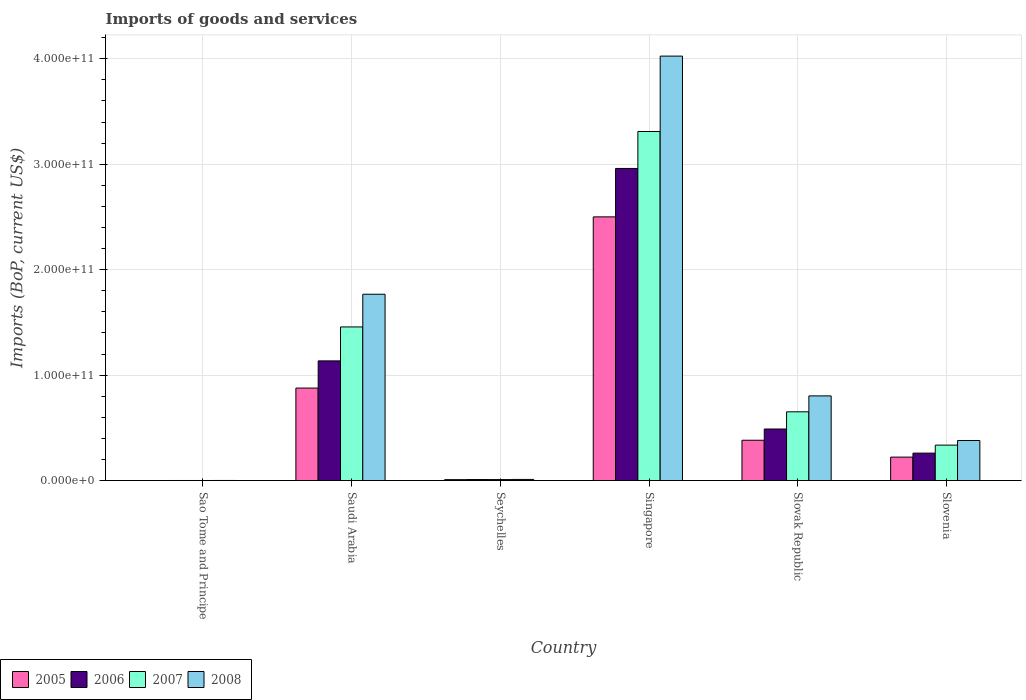How many different coloured bars are there?
Keep it short and to the point. 4. How many groups of bars are there?
Offer a very short reply. 6. Are the number of bars on each tick of the X-axis equal?
Your answer should be compact. Yes. How many bars are there on the 1st tick from the right?
Your answer should be very brief. 4. What is the label of the 6th group of bars from the left?
Offer a very short reply. Slovenia. In how many cases, is the number of bars for a given country not equal to the number of legend labels?
Provide a short and direct response. 0. What is the amount spent on imports in 2007 in Singapore?
Ensure brevity in your answer.  3.31e+11. Across all countries, what is the maximum amount spent on imports in 2006?
Your response must be concise. 2.96e+11. Across all countries, what is the minimum amount spent on imports in 2005?
Your answer should be very brief. 5.27e+07. In which country was the amount spent on imports in 2008 maximum?
Make the answer very short. Singapore. In which country was the amount spent on imports in 2007 minimum?
Your response must be concise. Sao Tome and Principe. What is the total amount spent on imports in 2006 in the graph?
Give a very brief answer. 4.85e+11. What is the difference between the amount spent on imports in 2008 in Saudi Arabia and that in Seychelles?
Your response must be concise. 1.76e+11. What is the difference between the amount spent on imports in 2006 in Seychelles and the amount spent on imports in 2007 in Sao Tome and Principe?
Provide a short and direct response. 9.01e+08. What is the average amount spent on imports in 2008 per country?
Make the answer very short. 1.16e+11. What is the difference between the amount spent on imports of/in 2008 and amount spent on imports of/in 2005 in Slovenia?
Offer a terse response. 1.58e+1. In how many countries, is the amount spent on imports in 2007 greater than 300000000000 US$?
Provide a short and direct response. 1. What is the ratio of the amount spent on imports in 2006 in Saudi Arabia to that in Seychelles?
Ensure brevity in your answer.  115.28. Is the difference between the amount spent on imports in 2008 in Sao Tome and Principe and Seychelles greater than the difference between the amount spent on imports in 2005 in Sao Tome and Principe and Seychelles?
Give a very brief answer. No. What is the difference between the highest and the second highest amount spent on imports in 2008?
Offer a terse response. 2.26e+11. What is the difference between the highest and the lowest amount spent on imports in 2008?
Provide a short and direct response. 4.02e+11. In how many countries, is the amount spent on imports in 2005 greater than the average amount spent on imports in 2005 taken over all countries?
Give a very brief answer. 2. What does the 1st bar from the right in Slovak Republic represents?
Provide a short and direct response. 2008. Is it the case that in every country, the sum of the amount spent on imports in 2007 and amount spent on imports in 2005 is greater than the amount spent on imports in 2006?
Offer a terse response. Yes. Are all the bars in the graph horizontal?
Make the answer very short. No. How many countries are there in the graph?
Keep it short and to the point. 6. What is the difference between two consecutive major ticks on the Y-axis?
Your answer should be compact. 1.00e+11. Are the values on the major ticks of Y-axis written in scientific E-notation?
Your answer should be compact. Yes. How many legend labels are there?
Provide a short and direct response. 4. What is the title of the graph?
Ensure brevity in your answer.  Imports of goods and services. What is the label or title of the X-axis?
Make the answer very short. Country. What is the label or title of the Y-axis?
Offer a terse response. Imports (BoP, current US$). What is the Imports (BoP, current US$) of 2005 in Sao Tome and Principe?
Your response must be concise. 5.27e+07. What is the Imports (BoP, current US$) of 2006 in Sao Tome and Principe?
Provide a short and direct response. 7.70e+07. What is the Imports (BoP, current US$) of 2007 in Sao Tome and Principe?
Your answer should be very brief. 8.35e+07. What is the Imports (BoP, current US$) in 2008 in Sao Tome and Principe?
Give a very brief answer. 1.14e+08. What is the Imports (BoP, current US$) in 2005 in Saudi Arabia?
Your answer should be very brief. 8.77e+1. What is the Imports (BoP, current US$) of 2006 in Saudi Arabia?
Your answer should be very brief. 1.13e+11. What is the Imports (BoP, current US$) in 2007 in Saudi Arabia?
Offer a terse response. 1.46e+11. What is the Imports (BoP, current US$) in 2008 in Saudi Arabia?
Give a very brief answer. 1.77e+11. What is the Imports (BoP, current US$) in 2005 in Seychelles?
Your response must be concise. 8.85e+08. What is the Imports (BoP, current US$) in 2006 in Seychelles?
Ensure brevity in your answer.  9.85e+08. What is the Imports (BoP, current US$) of 2007 in Seychelles?
Make the answer very short. 9.49e+08. What is the Imports (BoP, current US$) in 2008 in Seychelles?
Provide a short and direct response. 1.08e+09. What is the Imports (BoP, current US$) in 2005 in Singapore?
Ensure brevity in your answer.  2.50e+11. What is the Imports (BoP, current US$) of 2006 in Singapore?
Offer a terse response. 2.96e+11. What is the Imports (BoP, current US$) of 2007 in Singapore?
Make the answer very short. 3.31e+11. What is the Imports (BoP, current US$) in 2008 in Singapore?
Give a very brief answer. 4.03e+11. What is the Imports (BoP, current US$) of 2005 in Slovak Republic?
Keep it short and to the point. 3.82e+1. What is the Imports (BoP, current US$) of 2006 in Slovak Republic?
Ensure brevity in your answer.  4.89e+1. What is the Imports (BoP, current US$) in 2007 in Slovak Republic?
Provide a succinct answer. 6.52e+1. What is the Imports (BoP, current US$) of 2008 in Slovak Republic?
Your answer should be very brief. 8.03e+1. What is the Imports (BoP, current US$) in 2005 in Slovenia?
Offer a terse response. 2.22e+1. What is the Imports (BoP, current US$) of 2006 in Slovenia?
Make the answer very short. 2.60e+1. What is the Imports (BoP, current US$) in 2007 in Slovenia?
Your response must be concise. 3.36e+1. What is the Imports (BoP, current US$) in 2008 in Slovenia?
Make the answer very short. 3.80e+1. Across all countries, what is the maximum Imports (BoP, current US$) of 2005?
Offer a terse response. 2.50e+11. Across all countries, what is the maximum Imports (BoP, current US$) of 2006?
Ensure brevity in your answer.  2.96e+11. Across all countries, what is the maximum Imports (BoP, current US$) in 2007?
Your response must be concise. 3.31e+11. Across all countries, what is the maximum Imports (BoP, current US$) in 2008?
Offer a terse response. 4.03e+11. Across all countries, what is the minimum Imports (BoP, current US$) in 2005?
Ensure brevity in your answer.  5.27e+07. Across all countries, what is the minimum Imports (BoP, current US$) in 2006?
Offer a terse response. 7.70e+07. Across all countries, what is the minimum Imports (BoP, current US$) in 2007?
Make the answer very short. 8.35e+07. Across all countries, what is the minimum Imports (BoP, current US$) of 2008?
Your response must be concise. 1.14e+08. What is the total Imports (BoP, current US$) in 2005 in the graph?
Offer a terse response. 3.99e+11. What is the total Imports (BoP, current US$) of 2006 in the graph?
Your answer should be very brief. 4.85e+11. What is the total Imports (BoP, current US$) of 2007 in the graph?
Offer a terse response. 5.77e+11. What is the total Imports (BoP, current US$) in 2008 in the graph?
Provide a succinct answer. 6.99e+11. What is the difference between the Imports (BoP, current US$) of 2005 in Sao Tome and Principe and that in Saudi Arabia?
Offer a terse response. -8.77e+1. What is the difference between the Imports (BoP, current US$) in 2006 in Sao Tome and Principe and that in Saudi Arabia?
Your answer should be very brief. -1.13e+11. What is the difference between the Imports (BoP, current US$) of 2007 in Sao Tome and Principe and that in Saudi Arabia?
Your answer should be compact. -1.46e+11. What is the difference between the Imports (BoP, current US$) of 2008 in Sao Tome and Principe and that in Saudi Arabia?
Make the answer very short. -1.77e+11. What is the difference between the Imports (BoP, current US$) of 2005 in Sao Tome and Principe and that in Seychelles?
Ensure brevity in your answer.  -8.32e+08. What is the difference between the Imports (BoP, current US$) in 2006 in Sao Tome and Principe and that in Seychelles?
Offer a terse response. -9.08e+08. What is the difference between the Imports (BoP, current US$) of 2007 in Sao Tome and Principe and that in Seychelles?
Your answer should be compact. -8.65e+08. What is the difference between the Imports (BoP, current US$) in 2008 in Sao Tome and Principe and that in Seychelles?
Ensure brevity in your answer.  -9.71e+08. What is the difference between the Imports (BoP, current US$) of 2005 in Sao Tome and Principe and that in Singapore?
Your answer should be compact. -2.50e+11. What is the difference between the Imports (BoP, current US$) in 2006 in Sao Tome and Principe and that in Singapore?
Provide a short and direct response. -2.96e+11. What is the difference between the Imports (BoP, current US$) of 2007 in Sao Tome and Principe and that in Singapore?
Your answer should be compact. -3.31e+11. What is the difference between the Imports (BoP, current US$) in 2008 in Sao Tome and Principe and that in Singapore?
Give a very brief answer. -4.02e+11. What is the difference between the Imports (BoP, current US$) of 2005 in Sao Tome and Principe and that in Slovak Republic?
Ensure brevity in your answer.  -3.82e+1. What is the difference between the Imports (BoP, current US$) in 2006 in Sao Tome and Principe and that in Slovak Republic?
Offer a very short reply. -4.88e+1. What is the difference between the Imports (BoP, current US$) in 2007 in Sao Tome and Principe and that in Slovak Republic?
Offer a terse response. -6.51e+1. What is the difference between the Imports (BoP, current US$) of 2008 in Sao Tome and Principe and that in Slovak Republic?
Give a very brief answer. -8.02e+1. What is the difference between the Imports (BoP, current US$) of 2005 in Sao Tome and Principe and that in Slovenia?
Provide a succinct answer. -2.22e+1. What is the difference between the Imports (BoP, current US$) in 2006 in Sao Tome and Principe and that in Slovenia?
Give a very brief answer. -2.60e+1. What is the difference between the Imports (BoP, current US$) of 2007 in Sao Tome and Principe and that in Slovenia?
Ensure brevity in your answer.  -3.35e+1. What is the difference between the Imports (BoP, current US$) of 2008 in Sao Tome and Principe and that in Slovenia?
Provide a short and direct response. -3.79e+1. What is the difference between the Imports (BoP, current US$) in 2005 in Saudi Arabia and that in Seychelles?
Make the answer very short. 8.68e+1. What is the difference between the Imports (BoP, current US$) in 2006 in Saudi Arabia and that in Seychelles?
Ensure brevity in your answer.  1.13e+11. What is the difference between the Imports (BoP, current US$) in 2007 in Saudi Arabia and that in Seychelles?
Make the answer very short. 1.45e+11. What is the difference between the Imports (BoP, current US$) of 2008 in Saudi Arabia and that in Seychelles?
Make the answer very short. 1.76e+11. What is the difference between the Imports (BoP, current US$) of 2005 in Saudi Arabia and that in Singapore?
Provide a short and direct response. -1.62e+11. What is the difference between the Imports (BoP, current US$) in 2006 in Saudi Arabia and that in Singapore?
Keep it short and to the point. -1.82e+11. What is the difference between the Imports (BoP, current US$) in 2007 in Saudi Arabia and that in Singapore?
Give a very brief answer. -1.85e+11. What is the difference between the Imports (BoP, current US$) in 2008 in Saudi Arabia and that in Singapore?
Make the answer very short. -2.26e+11. What is the difference between the Imports (BoP, current US$) in 2005 in Saudi Arabia and that in Slovak Republic?
Offer a terse response. 4.95e+1. What is the difference between the Imports (BoP, current US$) in 2006 in Saudi Arabia and that in Slovak Republic?
Your response must be concise. 6.46e+1. What is the difference between the Imports (BoP, current US$) in 2007 in Saudi Arabia and that in Slovak Republic?
Make the answer very short. 8.05e+1. What is the difference between the Imports (BoP, current US$) of 2008 in Saudi Arabia and that in Slovak Republic?
Your response must be concise. 9.64e+1. What is the difference between the Imports (BoP, current US$) in 2005 in Saudi Arabia and that in Slovenia?
Your response must be concise. 6.55e+1. What is the difference between the Imports (BoP, current US$) in 2006 in Saudi Arabia and that in Slovenia?
Your answer should be very brief. 8.75e+1. What is the difference between the Imports (BoP, current US$) of 2007 in Saudi Arabia and that in Slovenia?
Keep it short and to the point. 1.12e+11. What is the difference between the Imports (BoP, current US$) of 2008 in Saudi Arabia and that in Slovenia?
Offer a very short reply. 1.39e+11. What is the difference between the Imports (BoP, current US$) in 2005 in Seychelles and that in Singapore?
Your response must be concise. -2.49e+11. What is the difference between the Imports (BoP, current US$) of 2006 in Seychelles and that in Singapore?
Your answer should be very brief. -2.95e+11. What is the difference between the Imports (BoP, current US$) of 2007 in Seychelles and that in Singapore?
Offer a very short reply. -3.30e+11. What is the difference between the Imports (BoP, current US$) of 2008 in Seychelles and that in Singapore?
Provide a short and direct response. -4.01e+11. What is the difference between the Imports (BoP, current US$) in 2005 in Seychelles and that in Slovak Republic?
Offer a very short reply. -3.74e+1. What is the difference between the Imports (BoP, current US$) in 2006 in Seychelles and that in Slovak Republic?
Keep it short and to the point. -4.79e+1. What is the difference between the Imports (BoP, current US$) in 2007 in Seychelles and that in Slovak Republic?
Offer a very short reply. -6.43e+1. What is the difference between the Imports (BoP, current US$) in 2008 in Seychelles and that in Slovak Republic?
Provide a short and direct response. -7.92e+1. What is the difference between the Imports (BoP, current US$) of 2005 in Seychelles and that in Slovenia?
Keep it short and to the point. -2.14e+1. What is the difference between the Imports (BoP, current US$) of 2006 in Seychelles and that in Slovenia?
Your answer should be compact. -2.51e+1. What is the difference between the Imports (BoP, current US$) in 2007 in Seychelles and that in Slovenia?
Provide a short and direct response. -3.27e+1. What is the difference between the Imports (BoP, current US$) of 2008 in Seychelles and that in Slovenia?
Give a very brief answer. -3.69e+1. What is the difference between the Imports (BoP, current US$) of 2005 in Singapore and that in Slovak Republic?
Your answer should be compact. 2.12e+11. What is the difference between the Imports (BoP, current US$) in 2006 in Singapore and that in Slovak Republic?
Give a very brief answer. 2.47e+11. What is the difference between the Imports (BoP, current US$) of 2007 in Singapore and that in Slovak Republic?
Your answer should be compact. 2.66e+11. What is the difference between the Imports (BoP, current US$) in 2008 in Singapore and that in Slovak Republic?
Provide a succinct answer. 3.22e+11. What is the difference between the Imports (BoP, current US$) in 2005 in Singapore and that in Slovenia?
Provide a succinct answer. 2.28e+11. What is the difference between the Imports (BoP, current US$) in 2006 in Singapore and that in Slovenia?
Your answer should be very brief. 2.70e+11. What is the difference between the Imports (BoP, current US$) of 2007 in Singapore and that in Slovenia?
Your answer should be very brief. 2.97e+11. What is the difference between the Imports (BoP, current US$) in 2008 in Singapore and that in Slovenia?
Provide a short and direct response. 3.64e+11. What is the difference between the Imports (BoP, current US$) in 2005 in Slovak Republic and that in Slovenia?
Give a very brief answer. 1.60e+1. What is the difference between the Imports (BoP, current US$) in 2006 in Slovak Republic and that in Slovenia?
Ensure brevity in your answer.  2.29e+1. What is the difference between the Imports (BoP, current US$) in 2007 in Slovak Republic and that in Slovenia?
Give a very brief answer. 3.16e+1. What is the difference between the Imports (BoP, current US$) of 2008 in Slovak Republic and that in Slovenia?
Offer a terse response. 4.23e+1. What is the difference between the Imports (BoP, current US$) in 2005 in Sao Tome and Principe and the Imports (BoP, current US$) in 2006 in Saudi Arabia?
Provide a short and direct response. -1.13e+11. What is the difference between the Imports (BoP, current US$) in 2005 in Sao Tome and Principe and the Imports (BoP, current US$) in 2007 in Saudi Arabia?
Offer a very short reply. -1.46e+11. What is the difference between the Imports (BoP, current US$) of 2005 in Sao Tome and Principe and the Imports (BoP, current US$) of 2008 in Saudi Arabia?
Your response must be concise. -1.77e+11. What is the difference between the Imports (BoP, current US$) in 2006 in Sao Tome and Principe and the Imports (BoP, current US$) in 2007 in Saudi Arabia?
Offer a very short reply. -1.46e+11. What is the difference between the Imports (BoP, current US$) in 2006 in Sao Tome and Principe and the Imports (BoP, current US$) in 2008 in Saudi Arabia?
Your response must be concise. -1.77e+11. What is the difference between the Imports (BoP, current US$) of 2007 in Sao Tome and Principe and the Imports (BoP, current US$) of 2008 in Saudi Arabia?
Your answer should be very brief. -1.77e+11. What is the difference between the Imports (BoP, current US$) of 2005 in Sao Tome and Principe and the Imports (BoP, current US$) of 2006 in Seychelles?
Keep it short and to the point. -9.32e+08. What is the difference between the Imports (BoP, current US$) in 2005 in Sao Tome and Principe and the Imports (BoP, current US$) in 2007 in Seychelles?
Keep it short and to the point. -8.96e+08. What is the difference between the Imports (BoP, current US$) in 2005 in Sao Tome and Principe and the Imports (BoP, current US$) in 2008 in Seychelles?
Provide a short and direct response. -1.03e+09. What is the difference between the Imports (BoP, current US$) of 2006 in Sao Tome and Principe and the Imports (BoP, current US$) of 2007 in Seychelles?
Your response must be concise. -8.72e+08. What is the difference between the Imports (BoP, current US$) in 2006 in Sao Tome and Principe and the Imports (BoP, current US$) in 2008 in Seychelles?
Give a very brief answer. -1.01e+09. What is the difference between the Imports (BoP, current US$) in 2007 in Sao Tome and Principe and the Imports (BoP, current US$) in 2008 in Seychelles?
Keep it short and to the point. -1.00e+09. What is the difference between the Imports (BoP, current US$) of 2005 in Sao Tome and Principe and the Imports (BoP, current US$) of 2006 in Singapore?
Give a very brief answer. -2.96e+11. What is the difference between the Imports (BoP, current US$) in 2005 in Sao Tome and Principe and the Imports (BoP, current US$) in 2007 in Singapore?
Your response must be concise. -3.31e+11. What is the difference between the Imports (BoP, current US$) in 2005 in Sao Tome and Principe and the Imports (BoP, current US$) in 2008 in Singapore?
Provide a succinct answer. -4.02e+11. What is the difference between the Imports (BoP, current US$) in 2006 in Sao Tome and Principe and the Imports (BoP, current US$) in 2007 in Singapore?
Keep it short and to the point. -3.31e+11. What is the difference between the Imports (BoP, current US$) in 2006 in Sao Tome and Principe and the Imports (BoP, current US$) in 2008 in Singapore?
Your answer should be very brief. -4.02e+11. What is the difference between the Imports (BoP, current US$) in 2007 in Sao Tome and Principe and the Imports (BoP, current US$) in 2008 in Singapore?
Ensure brevity in your answer.  -4.02e+11. What is the difference between the Imports (BoP, current US$) of 2005 in Sao Tome and Principe and the Imports (BoP, current US$) of 2006 in Slovak Republic?
Your response must be concise. -4.89e+1. What is the difference between the Imports (BoP, current US$) in 2005 in Sao Tome and Principe and the Imports (BoP, current US$) in 2007 in Slovak Republic?
Provide a short and direct response. -6.52e+1. What is the difference between the Imports (BoP, current US$) in 2005 in Sao Tome and Principe and the Imports (BoP, current US$) in 2008 in Slovak Republic?
Provide a short and direct response. -8.02e+1. What is the difference between the Imports (BoP, current US$) of 2006 in Sao Tome and Principe and the Imports (BoP, current US$) of 2007 in Slovak Republic?
Offer a terse response. -6.51e+1. What is the difference between the Imports (BoP, current US$) in 2006 in Sao Tome and Principe and the Imports (BoP, current US$) in 2008 in Slovak Republic?
Your response must be concise. -8.02e+1. What is the difference between the Imports (BoP, current US$) in 2007 in Sao Tome and Principe and the Imports (BoP, current US$) in 2008 in Slovak Republic?
Make the answer very short. -8.02e+1. What is the difference between the Imports (BoP, current US$) of 2005 in Sao Tome and Principe and the Imports (BoP, current US$) of 2006 in Slovenia?
Offer a terse response. -2.60e+1. What is the difference between the Imports (BoP, current US$) in 2005 in Sao Tome and Principe and the Imports (BoP, current US$) in 2007 in Slovenia?
Provide a short and direct response. -3.36e+1. What is the difference between the Imports (BoP, current US$) in 2005 in Sao Tome and Principe and the Imports (BoP, current US$) in 2008 in Slovenia?
Offer a very short reply. -3.80e+1. What is the difference between the Imports (BoP, current US$) in 2006 in Sao Tome and Principe and the Imports (BoP, current US$) in 2007 in Slovenia?
Give a very brief answer. -3.36e+1. What is the difference between the Imports (BoP, current US$) in 2006 in Sao Tome and Principe and the Imports (BoP, current US$) in 2008 in Slovenia?
Your response must be concise. -3.79e+1. What is the difference between the Imports (BoP, current US$) of 2007 in Sao Tome and Principe and the Imports (BoP, current US$) of 2008 in Slovenia?
Give a very brief answer. -3.79e+1. What is the difference between the Imports (BoP, current US$) of 2005 in Saudi Arabia and the Imports (BoP, current US$) of 2006 in Seychelles?
Your response must be concise. 8.67e+1. What is the difference between the Imports (BoP, current US$) in 2005 in Saudi Arabia and the Imports (BoP, current US$) in 2007 in Seychelles?
Give a very brief answer. 8.68e+1. What is the difference between the Imports (BoP, current US$) of 2005 in Saudi Arabia and the Imports (BoP, current US$) of 2008 in Seychelles?
Your answer should be compact. 8.66e+1. What is the difference between the Imports (BoP, current US$) in 2006 in Saudi Arabia and the Imports (BoP, current US$) in 2007 in Seychelles?
Keep it short and to the point. 1.13e+11. What is the difference between the Imports (BoP, current US$) in 2006 in Saudi Arabia and the Imports (BoP, current US$) in 2008 in Seychelles?
Provide a succinct answer. 1.12e+11. What is the difference between the Imports (BoP, current US$) of 2007 in Saudi Arabia and the Imports (BoP, current US$) of 2008 in Seychelles?
Offer a terse response. 1.45e+11. What is the difference between the Imports (BoP, current US$) of 2005 in Saudi Arabia and the Imports (BoP, current US$) of 2006 in Singapore?
Offer a terse response. -2.08e+11. What is the difference between the Imports (BoP, current US$) in 2005 in Saudi Arabia and the Imports (BoP, current US$) in 2007 in Singapore?
Your answer should be compact. -2.43e+11. What is the difference between the Imports (BoP, current US$) of 2005 in Saudi Arabia and the Imports (BoP, current US$) of 2008 in Singapore?
Provide a short and direct response. -3.15e+11. What is the difference between the Imports (BoP, current US$) in 2006 in Saudi Arabia and the Imports (BoP, current US$) in 2007 in Singapore?
Ensure brevity in your answer.  -2.18e+11. What is the difference between the Imports (BoP, current US$) of 2006 in Saudi Arabia and the Imports (BoP, current US$) of 2008 in Singapore?
Give a very brief answer. -2.89e+11. What is the difference between the Imports (BoP, current US$) in 2007 in Saudi Arabia and the Imports (BoP, current US$) in 2008 in Singapore?
Your answer should be very brief. -2.57e+11. What is the difference between the Imports (BoP, current US$) in 2005 in Saudi Arabia and the Imports (BoP, current US$) in 2006 in Slovak Republic?
Your response must be concise. 3.88e+1. What is the difference between the Imports (BoP, current US$) in 2005 in Saudi Arabia and the Imports (BoP, current US$) in 2007 in Slovak Republic?
Offer a terse response. 2.25e+1. What is the difference between the Imports (BoP, current US$) of 2005 in Saudi Arabia and the Imports (BoP, current US$) of 2008 in Slovak Republic?
Ensure brevity in your answer.  7.42e+09. What is the difference between the Imports (BoP, current US$) of 2006 in Saudi Arabia and the Imports (BoP, current US$) of 2007 in Slovak Republic?
Provide a short and direct response. 4.83e+1. What is the difference between the Imports (BoP, current US$) in 2006 in Saudi Arabia and the Imports (BoP, current US$) in 2008 in Slovak Republic?
Your answer should be very brief. 3.32e+1. What is the difference between the Imports (BoP, current US$) of 2007 in Saudi Arabia and the Imports (BoP, current US$) of 2008 in Slovak Republic?
Provide a succinct answer. 6.54e+1. What is the difference between the Imports (BoP, current US$) in 2005 in Saudi Arabia and the Imports (BoP, current US$) in 2006 in Slovenia?
Provide a short and direct response. 6.17e+1. What is the difference between the Imports (BoP, current US$) in 2005 in Saudi Arabia and the Imports (BoP, current US$) in 2007 in Slovenia?
Ensure brevity in your answer.  5.41e+1. What is the difference between the Imports (BoP, current US$) of 2005 in Saudi Arabia and the Imports (BoP, current US$) of 2008 in Slovenia?
Your response must be concise. 4.97e+1. What is the difference between the Imports (BoP, current US$) in 2006 in Saudi Arabia and the Imports (BoP, current US$) in 2007 in Slovenia?
Offer a terse response. 7.99e+1. What is the difference between the Imports (BoP, current US$) in 2006 in Saudi Arabia and the Imports (BoP, current US$) in 2008 in Slovenia?
Give a very brief answer. 7.55e+1. What is the difference between the Imports (BoP, current US$) of 2007 in Saudi Arabia and the Imports (BoP, current US$) of 2008 in Slovenia?
Offer a very short reply. 1.08e+11. What is the difference between the Imports (BoP, current US$) in 2005 in Seychelles and the Imports (BoP, current US$) in 2006 in Singapore?
Keep it short and to the point. -2.95e+11. What is the difference between the Imports (BoP, current US$) in 2005 in Seychelles and the Imports (BoP, current US$) in 2007 in Singapore?
Ensure brevity in your answer.  -3.30e+11. What is the difference between the Imports (BoP, current US$) of 2005 in Seychelles and the Imports (BoP, current US$) of 2008 in Singapore?
Your answer should be very brief. -4.02e+11. What is the difference between the Imports (BoP, current US$) in 2006 in Seychelles and the Imports (BoP, current US$) in 2007 in Singapore?
Offer a very short reply. -3.30e+11. What is the difference between the Imports (BoP, current US$) of 2006 in Seychelles and the Imports (BoP, current US$) of 2008 in Singapore?
Your answer should be very brief. -4.02e+11. What is the difference between the Imports (BoP, current US$) of 2007 in Seychelles and the Imports (BoP, current US$) of 2008 in Singapore?
Make the answer very short. -4.02e+11. What is the difference between the Imports (BoP, current US$) in 2005 in Seychelles and the Imports (BoP, current US$) in 2006 in Slovak Republic?
Give a very brief answer. -4.80e+1. What is the difference between the Imports (BoP, current US$) in 2005 in Seychelles and the Imports (BoP, current US$) in 2007 in Slovak Republic?
Offer a very short reply. -6.43e+1. What is the difference between the Imports (BoP, current US$) of 2005 in Seychelles and the Imports (BoP, current US$) of 2008 in Slovak Republic?
Offer a very short reply. -7.94e+1. What is the difference between the Imports (BoP, current US$) in 2006 in Seychelles and the Imports (BoP, current US$) in 2007 in Slovak Republic?
Give a very brief answer. -6.42e+1. What is the difference between the Imports (BoP, current US$) of 2006 in Seychelles and the Imports (BoP, current US$) of 2008 in Slovak Republic?
Offer a terse response. -7.93e+1. What is the difference between the Imports (BoP, current US$) of 2007 in Seychelles and the Imports (BoP, current US$) of 2008 in Slovak Republic?
Offer a very short reply. -7.93e+1. What is the difference between the Imports (BoP, current US$) of 2005 in Seychelles and the Imports (BoP, current US$) of 2006 in Slovenia?
Offer a very short reply. -2.52e+1. What is the difference between the Imports (BoP, current US$) of 2005 in Seychelles and the Imports (BoP, current US$) of 2007 in Slovenia?
Provide a succinct answer. -3.27e+1. What is the difference between the Imports (BoP, current US$) of 2005 in Seychelles and the Imports (BoP, current US$) of 2008 in Slovenia?
Provide a short and direct response. -3.71e+1. What is the difference between the Imports (BoP, current US$) of 2006 in Seychelles and the Imports (BoP, current US$) of 2007 in Slovenia?
Keep it short and to the point. -3.26e+1. What is the difference between the Imports (BoP, current US$) in 2006 in Seychelles and the Imports (BoP, current US$) in 2008 in Slovenia?
Your answer should be compact. -3.70e+1. What is the difference between the Imports (BoP, current US$) of 2007 in Seychelles and the Imports (BoP, current US$) of 2008 in Slovenia?
Your answer should be compact. -3.71e+1. What is the difference between the Imports (BoP, current US$) of 2005 in Singapore and the Imports (BoP, current US$) of 2006 in Slovak Republic?
Provide a short and direct response. 2.01e+11. What is the difference between the Imports (BoP, current US$) of 2005 in Singapore and the Imports (BoP, current US$) of 2007 in Slovak Republic?
Make the answer very short. 1.85e+11. What is the difference between the Imports (BoP, current US$) of 2005 in Singapore and the Imports (BoP, current US$) of 2008 in Slovak Republic?
Provide a succinct answer. 1.70e+11. What is the difference between the Imports (BoP, current US$) of 2006 in Singapore and the Imports (BoP, current US$) of 2007 in Slovak Republic?
Give a very brief answer. 2.31e+11. What is the difference between the Imports (BoP, current US$) of 2006 in Singapore and the Imports (BoP, current US$) of 2008 in Slovak Republic?
Your response must be concise. 2.16e+11. What is the difference between the Imports (BoP, current US$) in 2007 in Singapore and the Imports (BoP, current US$) in 2008 in Slovak Republic?
Offer a very short reply. 2.51e+11. What is the difference between the Imports (BoP, current US$) in 2005 in Singapore and the Imports (BoP, current US$) in 2006 in Slovenia?
Offer a very short reply. 2.24e+11. What is the difference between the Imports (BoP, current US$) in 2005 in Singapore and the Imports (BoP, current US$) in 2007 in Slovenia?
Make the answer very short. 2.16e+11. What is the difference between the Imports (BoP, current US$) in 2005 in Singapore and the Imports (BoP, current US$) in 2008 in Slovenia?
Your answer should be very brief. 2.12e+11. What is the difference between the Imports (BoP, current US$) of 2006 in Singapore and the Imports (BoP, current US$) of 2007 in Slovenia?
Offer a very short reply. 2.62e+11. What is the difference between the Imports (BoP, current US$) of 2006 in Singapore and the Imports (BoP, current US$) of 2008 in Slovenia?
Make the answer very short. 2.58e+11. What is the difference between the Imports (BoP, current US$) of 2007 in Singapore and the Imports (BoP, current US$) of 2008 in Slovenia?
Provide a succinct answer. 2.93e+11. What is the difference between the Imports (BoP, current US$) in 2005 in Slovak Republic and the Imports (BoP, current US$) in 2006 in Slovenia?
Make the answer very short. 1.22e+1. What is the difference between the Imports (BoP, current US$) of 2005 in Slovak Republic and the Imports (BoP, current US$) of 2007 in Slovenia?
Give a very brief answer. 4.62e+09. What is the difference between the Imports (BoP, current US$) in 2005 in Slovak Republic and the Imports (BoP, current US$) in 2008 in Slovenia?
Give a very brief answer. 2.41e+08. What is the difference between the Imports (BoP, current US$) in 2006 in Slovak Republic and the Imports (BoP, current US$) in 2007 in Slovenia?
Ensure brevity in your answer.  1.53e+1. What is the difference between the Imports (BoP, current US$) of 2006 in Slovak Republic and the Imports (BoP, current US$) of 2008 in Slovenia?
Keep it short and to the point. 1.09e+1. What is the difference between the Imports (BoP, current US$) of 2007 in Slovak Republic and the Imports (BoP, current US$) of 2008 in Slovenia?
Your answer should be very brief. 2.72e+1. What is the average Imports (BoP, current US$) of 2005 per country?
Ensure brevity in your answer.  6.65e+1. What is the average Imports (BoP, current US$) of 2006 per country?
Your answer should be compact. 8.09e+1. What is the average Imports (BoP, current US$) in 2007 per country?
Provide a succinct answer. 9.61e+1. What is the average Imports (BoP, current US$) in 2008 per country?
Your answer should be compact. 1.16e+11. What is the difference between the Imports (BoP, current US$) of 2005 and Imports (BoP, current US$) of 2006 in Sao Tome and Principe?
Make the answer very short. -2.43e+07. What is the difference between the Imports (BoP, current US$) of 2005 and Imports (BoP, current US$) of 2007 in Sao Tome and Principe?
Offer a very short reply. -3.09e+07. What is the difference between the Imports (BoP, current US$) in 2005 and Imports (BoP, current US$) in 2008 in Sao Tome and Principe?
Provide a short and direct response. -6.09e+07. What is the difference between the Imports (BoP, current US$) in 2006 and Imports (BoP, current US$) in 2007 in Sao Tome and Principe?
Provide a short and direct response. -6.53e+06. What is the difference between the Imports (BoP, current US$) in 2006 and Imports (BoP, current US$) in 2008 in Sao Tome and Principe?
Give a very brief answer. -3.66e+07. What is the difference between the Imports (BoP, current US$) of 2007 and Imports (BoP, current US$) of 2008 in Sao Tome and Principe?
Ensure brevity in your answer.  -3.01e+07. What is the difference between the Imports (BoP, current US$) of 2005 and Imports (BoP, current US$) of 2006 in Saudi Arabia?
Give a very brief answer. -2.58e+1. What is the difference between the Imports (BoP, current US$) of 2005 and Imports (BoP, current US$) of 2007 in Saudi Arabia?
Provide a short and direct response. -5.80e+1. What is the difference between the Imports (BoP, current US$) of 2005 and Imports (BoP, current US$) of 2008 in Saudi Arabia?
Ensure brevity in your answer.  -8.90e+1. What is the difference between the Imports (BoP, current US$) in 2006 and Imports (BoP, current US$) in 2007 in Saudi Arabia?
Make the answer very short. -3.22e+1. What is the difference between the Imports (BoP, current US$) of 2006 and Imports (BoP, current US$) of 2008 in Saudi Arabia?
Offer a very short reply. -6.32e+1. What is the difference between the Imports (BoP, current US$) in 2007 and Imports (BoP, current US$) in 2008 in Saudi Arabia?
Give a very brief answer. -3.10e+1. What is the difference between the Imports (BoP, current US$) in 2005 and Imports (BoP, current US$) in 2006 in Seychelles?
Offer a very short reply. -9.96e+07. What is the difference between the Imports (BoP, current US$) in 2005 and Imports (BoP, current US$) in 2007 in Seychelles?
Make the answer very short. -6.38e+07. What is the difference between the Imports (BoP, current US$) in 2005 and Imports (BoP, current US$) in 2008 in Seychelles?
Keep it short and to the point. -1.99e+08. What is the difference between the Imports (BoP, current US$) of 2006 and Imports (BoP, current US$) of 2007 in Seychelles?
Your answer should be very brief. 3.58e+07. What is the difference between the Imports (BoP, current US$) of 2006 and Imports (BoP, current US$) of 2008 in Seychelles?
Provide a succinct answer. -9.99e+07. What is the difference between the Imports (BoP, current US$) in 2007 and Imports (BoP, current US$) in 2008 in Seychelles?
Offer a very short reply. -1.36e+08. What is the difference between the Imports (BoP, current US$) of 2005 and Imports (BoP, current US$) of 2006 in Singapore?
Provide a short and direct response. -4.59e+1. What is the difference between the Imports (BoP, current US$) in 2005 and Imports (BoP, current US$) in 2007 in Singapore?
Provide a succinct answer. -8.10e+1. What is the difference between the Imports (BoP, current US$) of 2005 and Imports (BoP, current US$) of 2008 in Singapore?
Offer a terse response. -1.52e+11. What is the difference between the Imports (BoP, current US$) in 2006 and Imports (BoP, current US$) in 2007 in Singapore?
Provide a short and direct response. -3.50e+1. What is the difference between the Imports (BoP, current US$) in 2006 and Imports (BoP, current US$) in 2008 in Singapore?
Keep it short and to the point. -1.07e+11. What is the difference between the Imports (BoP, current US$) in 2007 and Imports (BoP, current US$) in 2008 in Singapore?
Your response must be concise. -7.15e+1. What is the difference between the Imports (BoP, current US$) in 2005 and Imports (BoP, current US$) in 2006 in Slovak Republic?
Offer a very short reply. -1.07e+1. What is the difference between the Imports (BoP, current US$) in 2005 and Imports (BoP, current US$) in 2007 in Slovak Republic?
Offer a very short reply. -2.70e+1. What is the difference between the Imports (BoP, current US$) of 2005 and Imports (BoP, current US$) of 2008 in Slovak Republic?
Offer a terse response. -4.20e+1. What is the difference between the Imports (BoP, current US$) of 2006 and Imports (BoP, current US$) of 2007 in Slovak Republic?
Provide a succinct answer. -1.63e+1. What is the difference between the Imports (BoP, current US$) in 2006 and Imports (BoP, current US$) in 2008 in Slovak Republic?
Make the answer very short. -3.14e+1. What is the difference between the Imports (BoP, current US$) of 2007 and Imports (BoP, current US$) of 2008 in Slovak Republic?
Offer a terse response. -1.51e+1. What is the difference between the Imports (BoP, current US$) in 2005 and Imports (BoP, current US$) in 2006 in Slovenia?
Provide a succinct answer. -3.79e+09. What is the difference between the Imports (BoP, current US$) in 2005 and Imports (BoP, current US$) in 2007 in Slovenia?
Give a very brief answer. -1.14e+1. What is the difference between the Imports (BoP, current US$) of 2005 and Imports (BoP, current US$) of 2008 in Slovenia?
Keep it short and to the point. -1.58e+1. What is the difference between the Imports (BoP, current US$) in 2006 and Imports (BoP, current US$) in 2007 in Slovenia?
Keep it short and to the point. -7.59e+09. What is the difference between the Imports (BoP, current US$) in 2006 and Imports (BoP, current US$) in 2008 in Slovenia?
Offer a terse response. -1.20e+1. What is the difference between the Imports (BoP, current US$) of 2007 and Imports (BoP, current US$) of 2008 in Slovenia?
Your answer should be very brief. -4.38e+09. What is the ratio of the Imports (BoP, current US$) of 2005 in Sao Tome and Principe to that in Saudi Arabia?
Offer a very short reply. 0. What is the ratio of the Imports (BoP, current US$) in 2006 in Sao Tome and Principe to that in Saudi Arabia?
Make the answer very short. 0. What is the ratio of the Imports (BoP, current US$) in 2007 in Sao Tome and Principe to that in Saudi Arabia?
Your answer should be very brief. 0. What is the ratio of the Imports (BoP, current US$) of 2008 in Sao Tome and Principe to that in Saudi Arabia?
Provide a short and direct response. 0. What is the ratio of the Imports (BoP, current US$) in 2005 in Sao Tome and Principe to that in Seychelles?
Offer a very short reply. 0.06. What is the ratio of the Imports (BoP, current US$) of 2006 in Sao Tome and Principe to that in Seychelles?
Give a very brief answer. 0.08. What is the ratio of the Imports (BoP, current US$) of 2007 in Sao Tome and Principe to that in Seychelles?
Offer a terse response. 0.09. What is the ratio of the Imports (BoP, current US$) of 2008 in Sao Tome and Principe to that in Seychelles?
Keep it short and to the point. 0.1. What is the ratio of the Imports (BoP, current US$) of 2005 in Sao Tome and Principe to that in Singapore?
Offer a terse response. 0. What is the ratio of the Imports (BoP, current US$) of 2006 in Sao Tome and Principe to that in Singapore?
Make the answer very short. 0. What is the ratio of the Imports (BoP, current US$) of 2007 in Sao Tome and Principe to that in Singapore?
Make the answer very short. 0. What is the ratio of the Imports (BoP, current US$) of 2008 in Sao Tome and Principe to that in Singapore?
Your answer should be very brief. 0. What is the ratio of the Imports (BoP, current US$) of 2005 in Sao Tome and Principe to that in Slovak Republic?
Your answer should be compact. 0. What is the ratio of the Imports (BoP, current US$) of 2006 in Sao Tome and Principe to that in Slovak Republic?
Make the answer very short. 0. What is the ratio of the Imports (BoP, current US$) in 2007 in Sao Tome and Principe to that in Slovak Republic?
Provide a succinct answer. 0. What is the ratio of the Imports (BoP, current US$) in 2008 in Sao Tome and Principe to that in Slovak Republic?
Provide a short and direct response. 0. What is the ratio of the Imports (BoP, current US$) in 2005 in Sao Tome and Principe to that in Slovenia?
Provide a short and direct response. 0. What is the ratio of the Imports (BoP, current US$) in 2006 in Sao Tome and Principe to that in Slovenia?
Give a very brief answer. 0. What is the ratio of the Imports (BoP, current US$) in 2007 in Sao Tome and Principe to that in Slovenia?
Ensure brevity in your answer.  0. What is the ratio of the Imports (BoP, current US$) of 2008 in Sao Tome and Principe to that in Slovenia?
Offer a terse response. 0. What is the ratio of the Imports (BoP, current US$) in 2005 in Saudi Arabia to that in Seychelles?
Offer a terse response. 99.13. What is the ratio of the Imports (BoP, current US$) of 2006 in Saudi Arabia to that in Seychelles?
Your answer should be very brief. 115.28. What is the ratio of the Imports (BoP, current US$) in 2007 in Saudi Arabia to that in Seychelles?
Your response must be concise. 153.57. What is the ratio of the Imports (BoP, current US$) of 2008 in Saudi Arabia to that in Seychelles?
Your response must be concise. 162.94. What is the ratio of the Imports (BoP, current US$) in 2005 in Saudi Arabia to that in Singapore?
Provide a succinct answer. 0.35. What is the ratio of the Imports (BoP, current US$) in 2006 in Saudi Arabia to that in Singapore?
Provide a short and direct response. 0.38. What is the ratio of the Imports (BoP, current US$) of 2007 in Saudi Arabia to that in Singapore?
Provide a succinct answer. 0.44. What is the ratio of the Imports (BoP, current US$) in 2008 in Saudi Arabia to that in Singapore?
Provide a succinct answer. 0.44. What is the ratio of the Imports (BoP, current US$) of 2005 in Saudi Arabia to that in Slovak Republic?
Your answer should be compact. 2.29. What is the ratio of the Imports (BoP, current US$) of 2006 in Saudi Arabia to that in Slovak Republic?
Provide a succinct answer. 2.32. What is the ratio of the Imports (BoP, current US$) of 2007 in Saudi Arabia to that in Slovak Republic?
Keep it short and to the point. 2.23. What is the ratio of the Imports (BoP, current US$) of 2008 in Saudi Arabia to that in Slovak Republic?
Give a very brief answer. 2.2. What is the ratio of the Imports (BoP, current US$) of 2005 in Saudi Arabia to that in Slovenia?
Offer a very short reply. 3.94. What is the ratio of the Imports (BoP, current US$) of 2006 in Saudi Arabia to that in Slovenia?
Your response must be concise. 4.36. What is the ratio of the Imports (BoP, current US$) of 2007 in Saudi Arabia to that in Slovenia?
Make the answer very short. 4.33. What is the ratio of the Imports (BoP, current US$) in 2008 in Saudi Arabia to that in Slovenia?
Offer a very short reply. 4.65. What is the ratio of the Imports (BoP, current US$) of 2005 in Seychelles to that in Singapore?
Give a very brief answer. 0. What is the ratio of the Imports (BoP, current US$) of 2006 in Seychelles to that in Singapore?
Provide a short and direct response. 0. What is the ratio of the Imports (BoP, current US$) of 2007 in Seychelles to that in Singapore?
Offer a very short reply. 0. What is the ratio of the Imports (BoP, current US$) in 2008 in Seychelles to that in Singapore?
Offer a very short reply. 0. What is the ratio of the Imports (BoP, current US$) in 2005 in Seychelles to that in Slovak Republic?
Provide a succinct answer. 0.02. What is the ratio of the Imports (BoP, current US$) of 2006 in Seychelles to that in Slovak Republic?
Give a very brief answer. 0.02. What is the ratio of the Imports (BoP, current US$) of 2007 in Seychelles to that in Slovak Republic?
Give a very brief answer. 0.01. What is the ratio of the Imports (BoP, current US$) of 2008 in Seychelles to that in Slovak Republic?
Keep it short and to the point. 0.01. What is the ratio of the Imports (BoP, current US$) of 2005 in Seychelles to that in Slovenia?
Your answer should be very brief. 0.04. What is the ratio of the Imports (BoP, current US$) of 2006 in Seychelles to that in Slovenia?
Make the answer very short. 0.04. What is the ratio of the Imports (BoP, current US$) in 2007 in Seychelles to that in Slovenia?
Ensure brevity in your answer.  0.03. What is the ratio of the Imports (BoP, current US$) of 2008 in Seychelles to that in Slovenia?
Provide a succinct answer. 0.03. What is the ratio of the Imports (BoP, current US$) in 2005 in Singapore to that in Slovak Republic?
Offer a terse response. 6.54. What is the ratio of the Imports (BoP, current US$) of 2006 in Singapore to that in Slovak Republic?
Your response must be concise. 6.05. What is the ratio of the Imports (BoP, current US$) of 2007 in Singapore to that in Slovak Republic?
Your answer should be compact. 5.08. What is the ratio of the Imports (BoP, current US$) in 2008 in Singapore to that in Slovak Republic?
Give a very brief answer. 5.01. What is the ratio of the Imports (BoP, current US$) in 2005 in Singapore to that in Slovenia?
Make the answer very short. 11.24. What is the ratio of the Imports (BoP, current US$) of 2006 in Singapore to that in Slovenia?
Offer a very short reply. 11.37. What is the ratio of the Imports (BoP, current US$) of 2007 in Singapore to that in Slovenia?
Provide a succinct answer. 9.84. What is the ratio of the Imports (BoP, current US$) in 2008 in Singapore to that in Slovenia?
Provide a succinct answer. 10.59. What is the ratio of the Imports (BoP, current US$) in 2005 in Slovak Republic to that in Slovenia?
Keep it short and to the point. 1.72. What is the ratio of the Imports (BoP, current US$) in 2006 in Slovak Republic to that in Slovenia?
Provide a succinct answer. 1.88. What is the ratio of the Imports (BoP, current US$) in 2007 in Slovak Republic to that in Slovenia?
Offer a terse response. 1.94. What is the ratio of the Imports (BoP, current US$) in 2008 in Slovak Republic to that in Slovenia?
Your answer should be very brief. 2.11. What is the difference between the highest and the second highest Imports (BoP, current US$) in 2005?
Your response must be concise. 1.62e+11. What is the difference between the highest and the second highest Imports (BoP, current US$) of 2006?
Keep it short and to the point. 1.82e+11. What is the difference between the highest and the second highest Imports (BoP, current US$) in 2007?
Make the answer very short. 1.85e+11. What is the difference between the highest and the second highest Imports (BoP, current US$) in 2008?
Your answer should be compact. 2.26e+11. What is the difference between the highest and the lowest Imports (BoP, current US$) in 2005?
Keep it short and to the point. 2.50e+11. What is the difference between the highest and the lowest Imports (BoP, current US$) in 2006?
Your answer should be very brief. 2.96e+11. What is the difference between the highest and the lowest Imports (BoP, current US$) of 2007?
Your answer should be very brief. 3.31e+11. What is the difference between the highest and the lowest Imports (BoP, current US$) of 2008?
Ensure brevity in your answer.  4.02e+11. 